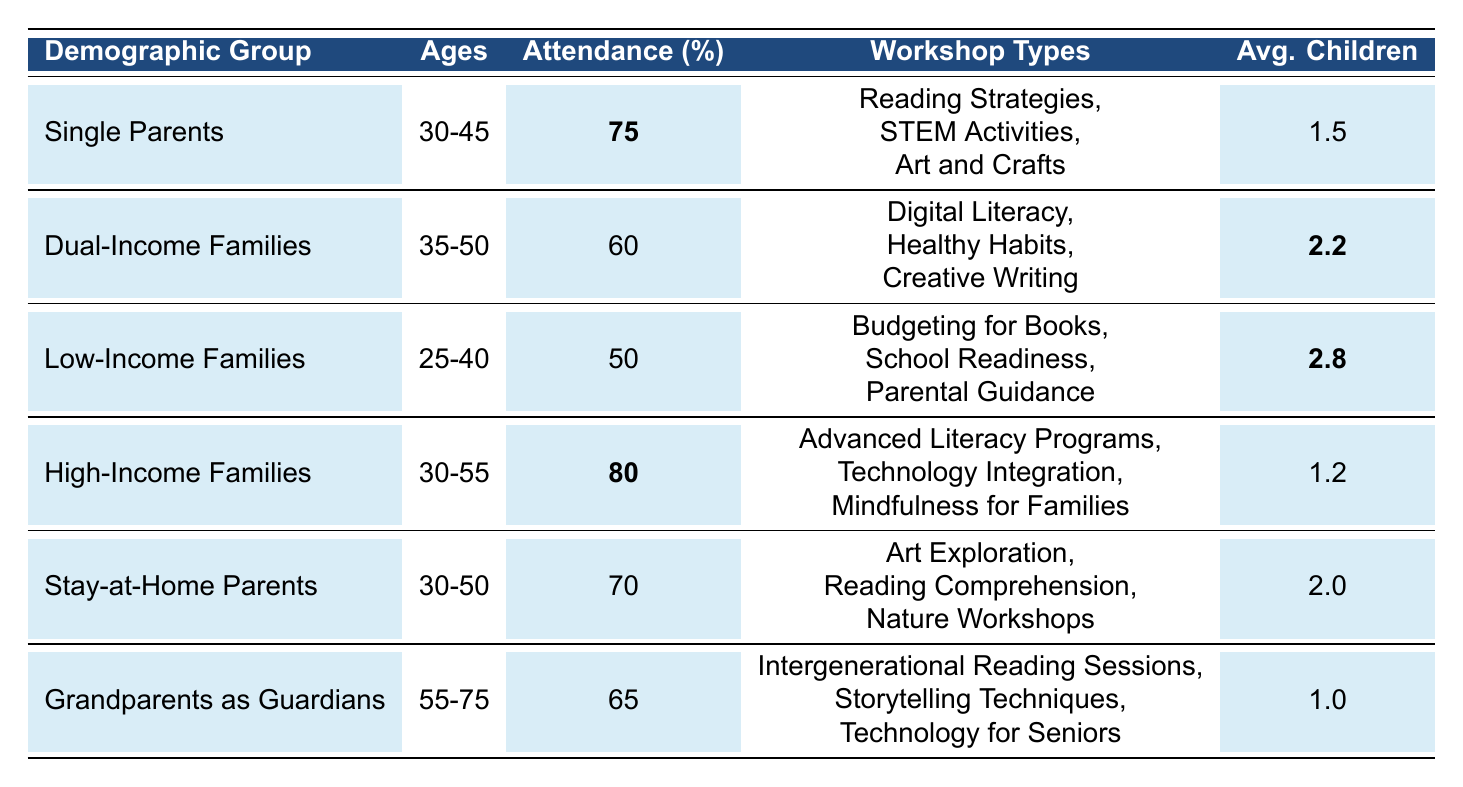What is the attendance percentage for High-Income Families? The attendance percentage for High-Income Families is clearly stated in the table as **80**.
Answer: 80 Which demographic group has the highest attendance percentage? By comparing the attendance percentages listed in the table, High-Income Families have the highest at **80**.
Answer: High-Income Families What types of workshops are offered to Single Parents? The table lists the workshop types for Single Parents: Reading Strategies, STEM Activities, and Art and Crafts.
Answer: Reading Strategies, STEM Activities, Art and Crafts How many average children do Low-Income Families have per parent? The table provides that Low-Income Families have an average of **2.8** children per parent.
Answer: 2.8 Which demographic group has the lowest percentage of attendance? The table indicates that Low-Income Families have the lowest attendance percentage at **50**.
Answer: Low-Income Families What is the total attendance percentage for Single Parents and Stay-at-Home Parents combined? The attendance percentage for Single Parents is **75** and for Stay-at-Home Parents is **70**. Adding these together gives **75 + 70 = 145**.
Answer: 145 Among all groups, which one has the fewest average children per parent, and what is that number? The table shows that Grandparents as Guardians have the fewest average children per parent at **1.0**.
Answer: Grandparents as Guardians, 1.0 Is it true that Dual-Income Families have an average of more children per parent than High-Income Families? The average for Dual-Income Families is **2.2** and for High-Income Families it is **1.2**. Since **2.2 > 1.2**, this statement is true.
Answer: Yes What is the difference in attendance percentage between Single Parents and Grandparents as Guardians? Single Parents have an attendance percentage of **75**, while Grandparents as Guardians have **65**. The difference is **75 - 65 = 10**.
Answer: 10 Which workshop type is associated with Grandparents as Guardians? The table lists the workshop types for Grandparents as Guardians: Intergenerational Reading Sessions, Storytelling Techniques, and Technology for Seniors.
Answer: Intergenerational Reading Sessions, Storytelling Techniques, Technology for Seniors 